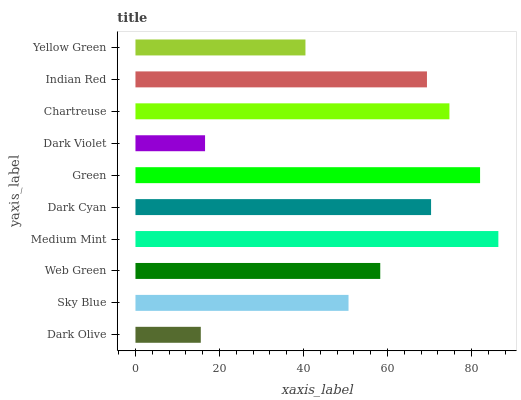Is Dark Olive the minimum?
Answer yes or no. Yes. Is Medium Mint the maximum?
Answer yes or no. Yes. Is Sky Blue the minimum?
Answer yes or no. No. Is Sky Blue the maximum?
Answer yes or no. No. Is Sky Blue greater than Dark Olive?
Answer yes or no. Yes. Is Dark Olive less than Sky Blue?
Answer yes or no. Yes. Is Dark Olive greater than Sky Blue?
Answer yes or no. No. Is Sky Blue less than Dark Olive?
Answer yes or no. No. Is Indian Red the high median?
Answer yes or no. Yes. Is Web Green the low median?
Answer yes or no. Yes. Is Web Green the high median?
Answer yes or no. No. Is Medium Mint the low median?
Answer yes or no. No. 